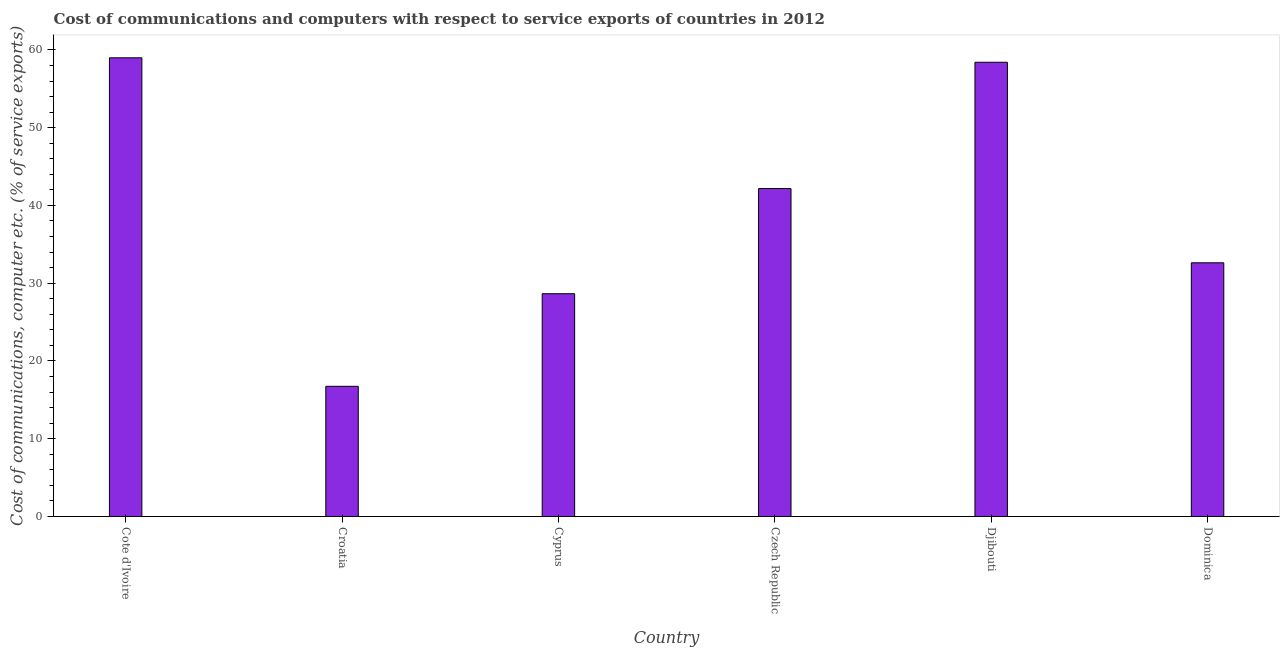Does the graph contain any zero values?
Offer a terse response. No. What is the title of the graph?
Keep it short and to the point. Cost of communications and computers with respect to service exports of countries in 2012. What is the label or title of the X-axis?
Make the answer very short. Country. What is the label or title of the Y-axis?
Provide a succinct answer. Cost of communications, computer etc. (% of service exports). What is the cost of communications and computer in Cyprus?
Keep it short and to the point. 28.65. Across all countries, what is the maximum cost of communications and computer?
Your answer should be very brief. 58.99. Across all countries, what is the minimum cost of communications and computer?
Keep it short and to the point. 16.74. In which country was the cost of communications and computer maximum?
Provide a short and direct response. Cote d'Ivoire. In which country was the cost of communications and computer minimum?
Keep it short and to the point. Croatia. What is the sum of the cost of communications and computer?
Your answer should be compact. 237.59. What is the difference between the cost of communications and computer in Cote d'Ivoire and Cyprus?
Your answer should be very brief. 30.34. What is the average cost of communications and computer per country?
Offer a very short reply. 39.6. What is the median cost of communications and computer?
Give a very brief answer. 37.4. What is the ratio of the cost of communications and computer in Croatia to that in Czech Republic?
Provide a short and direct response. 0.4. Is the difference between the cost of communications and computer in Cote d'Ivoire and Dominica greater than the difference between any two countries?
Offer a very short reply. No. What is the difference between the highest and the second highest cost of communications and computer?
Your answer should be compact. 0.57. What is the difference between the highest and the lowest cost of communications and computer?
Your answer should be compact. 42.25. Are all the bars in the graph horizontal?
Your answer should be compact. No. How many countries are there in the graph?
Ensure brevity in your answer.  6. What is the difference between two consecutive major ticks on the Y-axis?
Your answer should be very brief. 10. What is the Cost of communications, computer etc. (% of service exports) of Cote d'Ivoire?
Your response must be concise. 58.99. What is the Cost of communications, computer etc. (% of service exports) in Croatia?
Make the answer very short. 16.74. What is the Cost of communications, computer etc. (% of service exports) of Cyprus?
Provide a short and direct response. 28.65. What is the Cost of communications, computer etc. (% of service exports) of Czech Republic?
Keep it short and to the point. 42.17. What is the Cost of communications, computer etc. (% of service exports) of Djibouti?
Your answer should be very brief. 58.42. What is the Cost of communications, computer etc. (% of service exports) of Dominica?
Give a very brief answer. 32.63. What is the difference between the Cost of communications, computer etc. (% of service exports) in Cote d'Ivoire and Croatia?
Offer a terse response. 42.25. What is the difference between the Cost of communications, computer etc. (% of service exports) in Cote d'Ivoire and Cyprus?
Your response must be concise. 30.34. What is the difference between the Cost of communications, computer etc. (% of service exports) in Cote d'Ivoire and Czech Republic?
Offer a very short reply. 16.81. What is the difference between the Cost of communications, computer etc. (% of service exports) in Cote d'Ivoire and Djibouti?
Your answer should be compact. 0.57. What is the difference between the Cost of communications, computer etc. (% of service exports) in Cote d'Ivoire and Dominica?
Give a very brief answer. 26.36. What is the difference between the Cost of communications, computer etc. (% of service exports) in Croatia and Cyprus?
Offer a very short reply. -11.91. What is the difference between the Cost of communications, computer etc. (% of service exports) in Croatia and Czech Republic?
Make the answer very short. -25.43. What is the difference between the Cost of communications, computer etc. (% of service exports) in Croatia and Djibouti?
Make the answer very short. -41.68. What is the difference between the Cost of communications, computer etc. (% of service exports) in Croatia and Dominica?
Your answer should be very brief. -15.89. What is the difference between the Cost of communications, computer etc. (% of service exports) in Cyprus and Czech Republic?
Give a very brief answer. -13.52. What is the difference between the Cost of communications, computer etc. (% of service exports) in Cyprus and Djibouti?
Your answer should be compact. -29.77. What is the difference between the Cost of communications, computer etc. (% of service exports) in Cyprus and Dominica?
Keep it short and to the point. -3.98. What is the difference between the Cost of communications, computer etc. (% of service exports) in Czech Republic and Djibouti?
Ensure brevity in your answer.  -16.24. What is the difference between the Cost of communications, computer etc. (% of service exports) in Czech Republic and Dominica?
Your answer should be very brief. 9.55. What is the difference between the Cost of communications, computer etc. (% of service exports) in Djibouti and Dominica?
Give a very brief answer. 25.79. What is the ratio of the Cost of communications, computer etc. (% of service exports) in Cote d'Ivoire to that in Croatia?
Your response must be concise. 3.52. What is the ratio of the Cost of communications, computer etc. (% of service exports) in Cote d'Ivoire to that in Cyprus?
Offer a terse response. 2.06. What is the ratio of the Cost of communications, computer etc. (% of service exports) in Cote d'Ivoire to that in Czech Republic?
Give a very brief answer. 1.4. What is the ratio of the Cost of communications, computer etc. (% of service exports) in Cote d'Ivoire to that in Djibouti?
Your answer should be compact. 1.01. What is the ratio of the Cost of communications, computer etc. (% of service exports) in Cote d'Ivoire to that in Dominica?
Your answer should be very brief. 1.81. What is the ratio of the Cost of communications, computer etc. (% of service exports) in Croatia to that in Cyprus?
Your answer should be very brief. 0.58. What is the ratio of the Cost of communications, computer etc. (% of service exports) in Croatia to that in Czech Republic?
Ensure brevity in your answer.  0.4. What is the ratio of the Cost of communications, computer etc. (% of service exports) in Croatia to that in Djibouti?
Your answer should be compact. 0.29. What is the ratio of the Cost of communications, computer etc. (% of service exports) in Croatia to that in Dominica?
Ensure brevity in your answer.  0.51. What is the ratio of the Cost of communications, computer etc. (% of service exports) in Cyprus to that in Czech Republic?
Give a very brief answer. 0.68. What is the ratio of the Cost of communications, computer etc. (% of service exports) in Cyprus to that in Djibouti?
Your answer should be compact. 0.49. What is the ratio of the Cost of communications, computer etc. (% of service exports) in Cyprus to that in Dominica?
Offer a terse response. 0.88. What is the ratio of the Cost of communications, computer etc. (% of service exports) in Czech Republic to that in Djibouti?
Give a very brief answer. 0.72. What is the ratio of the Cost of communications, computer etc. (% of service exports) in Czech Republic to that in Dominica?
Offer a very short reply. 1.29. What is the ratio of the Cost of communications, computer etc. (% of service exports) in Djibouti to that in Dominica?
Your response must be concise. 1.79. 